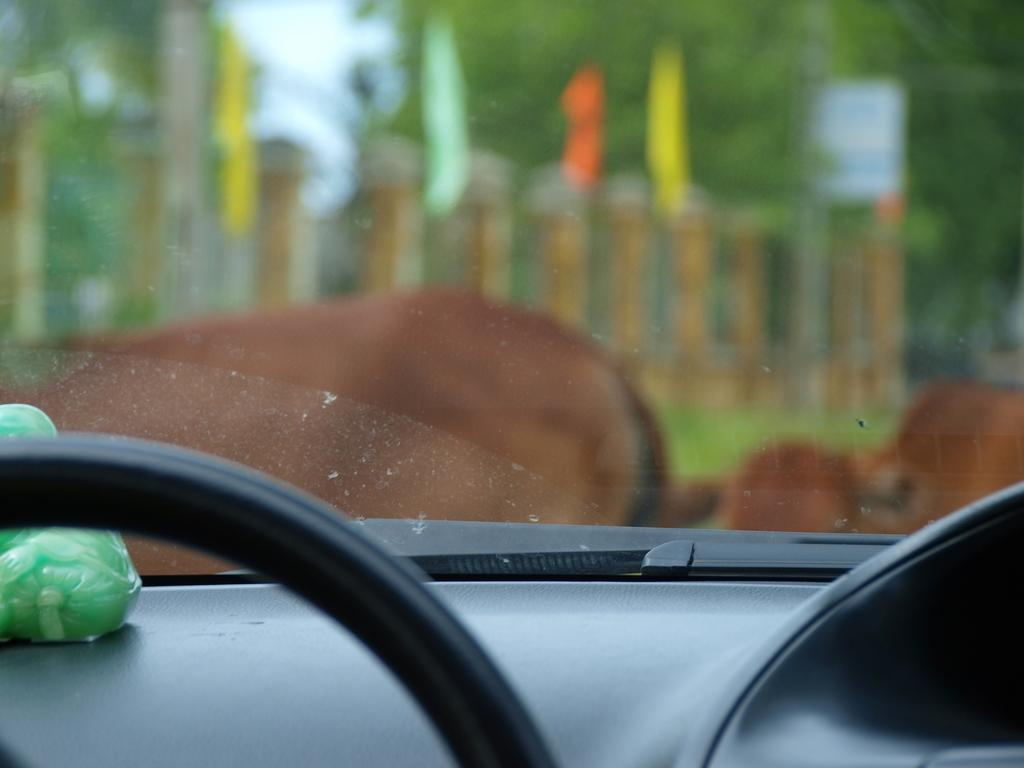What type of location is depicted in the image? The image is an inside view of a vehicle. What object can be seen inside the vehicle? There is a toy visible in the vehicle. What is used for controlling the direction of the vehicle? There is a steering wheel in the vehicle. What can be seen outside the vehicle through the glass? Flags, poles, a board, and trees are visible through the glass. What type of ice can be seen melting on the board through the glass? There is no ice visible in the image, and therefore no ice can be seen melting on the board through the glass. What type of lettuce is growing on the trees visible through the glass? There is no lettuce present in the image; the trees visible through the glass are not growing any vegetables. 